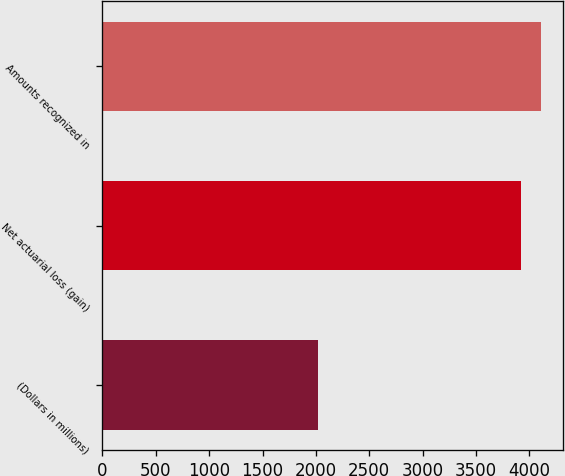Convert chart. <chart><loc_0><loc_0><loc_500><loc_500><bar_chart><fcel>(Dollars in millions)<fcel>Net actuarial loss (gain)<fcel>Amounts recognized in<nl><fcel>2015<fcel>3920<fcel>4110.5<nl></chart> 